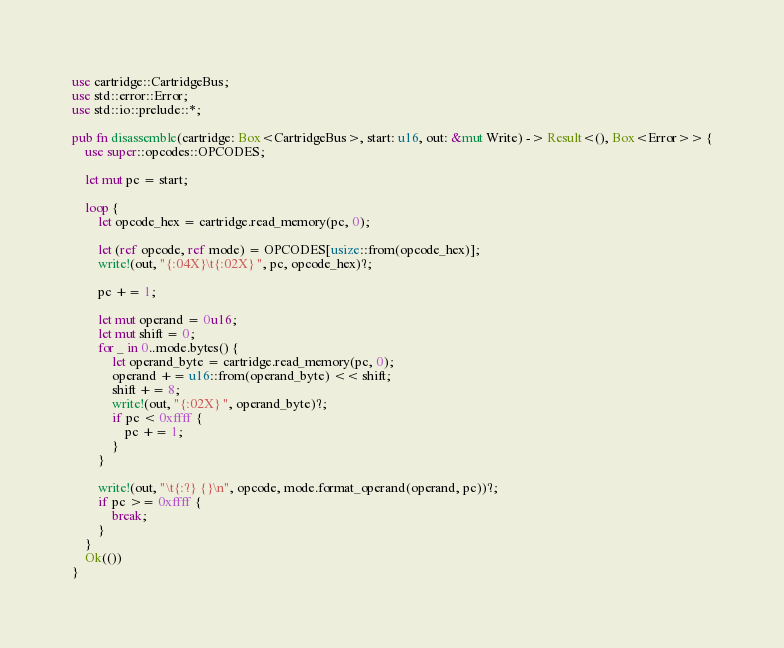Convert code to text. <code><loc_0><loc_0><loc_500><loc_500><_Rust_>use cartridge::CartridgeBus;
use std::error::Error;
use std::io::prelude::*;

pub fn disassemble(cartridge: Box<CartridgeBus>, start: u16, out: &mut Write) -> Result<(), Box<Error>> {
    use super::opcodes::OPCODES;

    let mut pc = start;

    loop {
        let opcode_hex = cartridge.read_memory(pc, 0);

        let (ref opcode, ref mode) = OPCODES[usize::from(opcode_hex)];
        write!(out, "{:04X}\t{:02X} ", pc, opcode_hex)?;

        pc += 1;

        let mut operand = 0u16;
        let mut shift = 0;
        for _ in 0..mode.bytes() {
            let operand_byte = cartridge.read_memory(pc, 0);
            operand += u16::from(operand_byte) << shift;
            shift += 8;
            write!(out, "{:02X} ", operand_byte)?;
            if pc < 0xffff {
                pc += 1;
            }
        }

        write!(out, "\t{:?} {}\n", opcode, mode.format_operand(operand, pc))?;
        if pc >= 0xffff {
            break;
        }
    }
    Ok(())
}</code> 